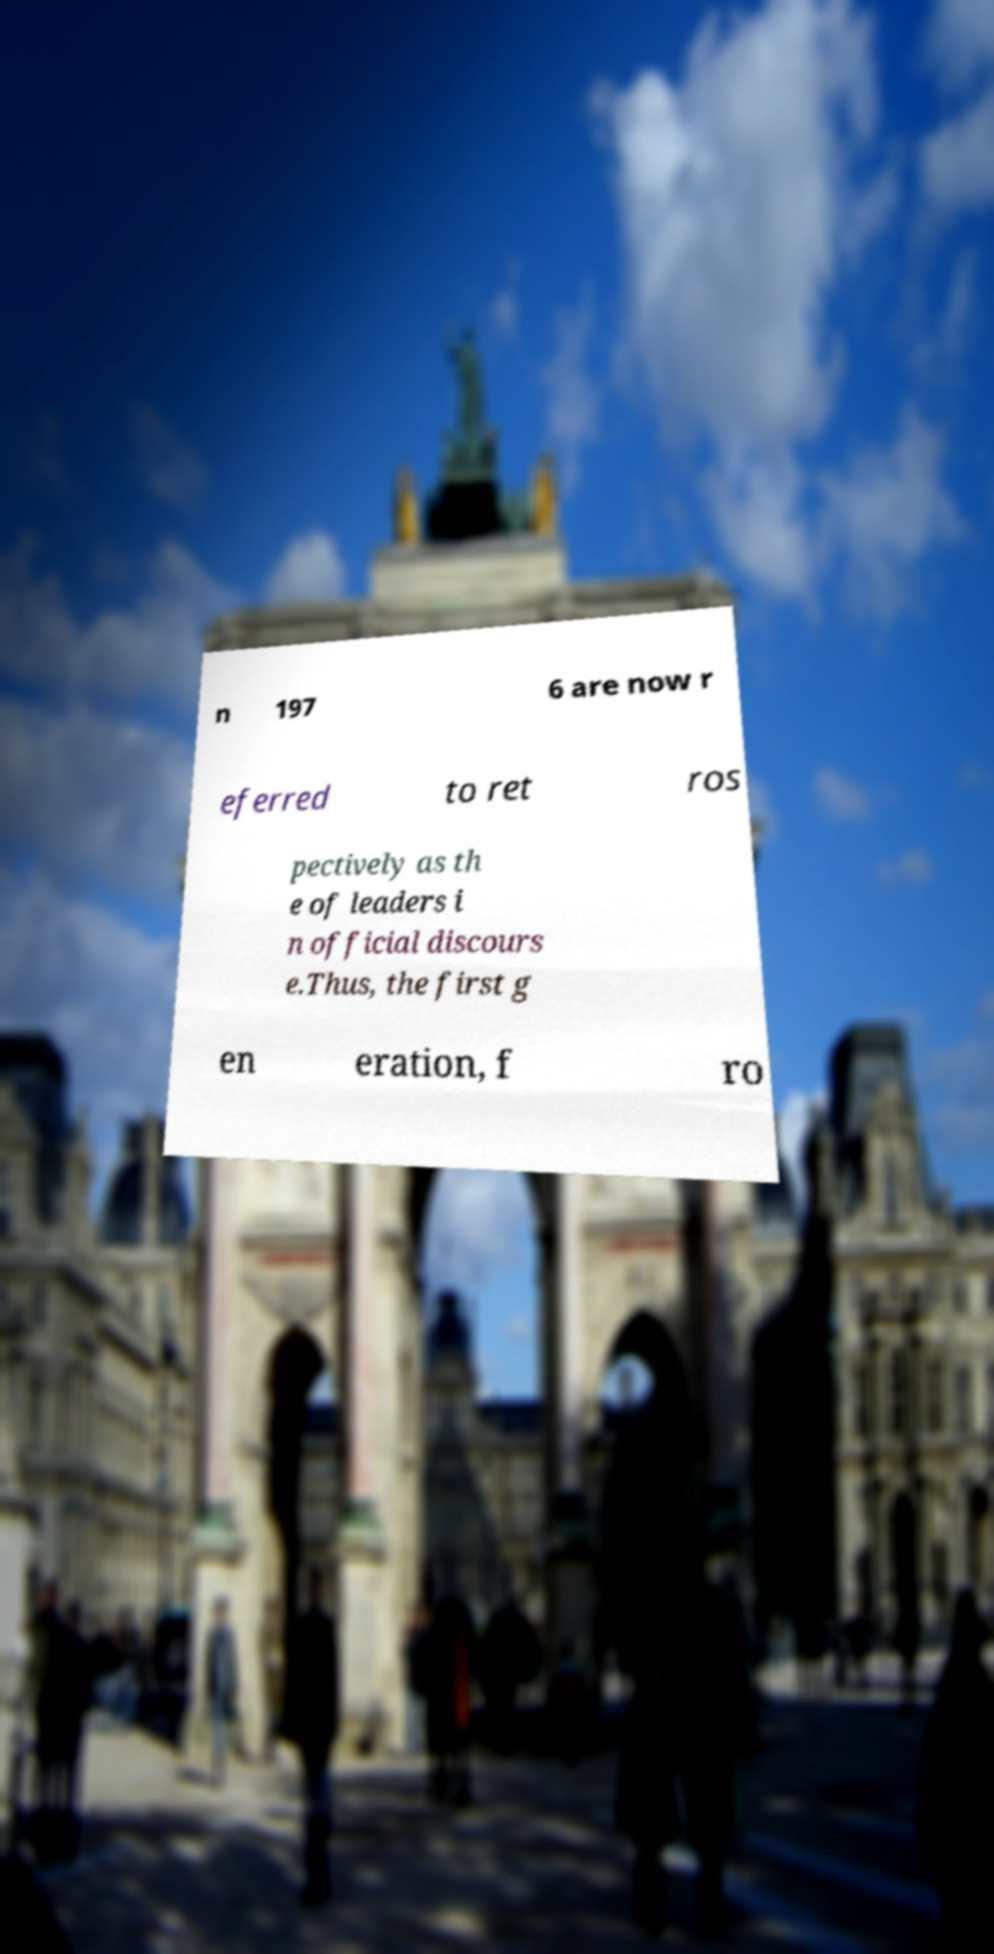Please identify and transcribe the text found in this image. n 197 6 are now r eferred to ret ros pectively as th e of leaders i n official discours e.Thus, the first g en eration, f ro 